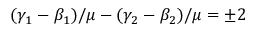Convert formula to latex. <formula><loc_0><loc_0><loc_500><loc_500>( \gamma _ { 1 } - \beta _ { 1 } ) / \mu - ( \gamma _ { 2 } - \beta _ { 2 } ) / \mu = \pm 2</formula> 